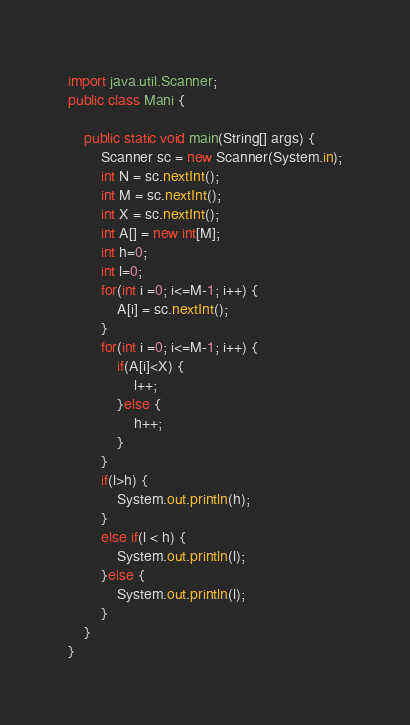<code> <loc_0><loc_0><loc_500><loc_500><_Java_>import java.util.Scanner;
public class Mani {

	public static void main(String[] args) {
		Scanner sc = new Scanner(System.in);
		int N = sc.nextInt();
		int M = sc.nextInt();
		int X = sc.nextInt();
		int A[] = new int[M];
		int h=0;
		int l=0;
		for(int i =0; i<=M-1; i++) {
			A[i] = sc.nextInt();
		}
		for(int i =0; i<=M-1; i++) {
			if(A[i]<X) {
				l++;
			}else {
				h++;
			}
		}
		if(l>h) {
			System.out.println(h);
		}
		else if(l < h) {
			System.out.println(l);
		}else {
			System.out.println(l);
		}
	}
}
</code> 